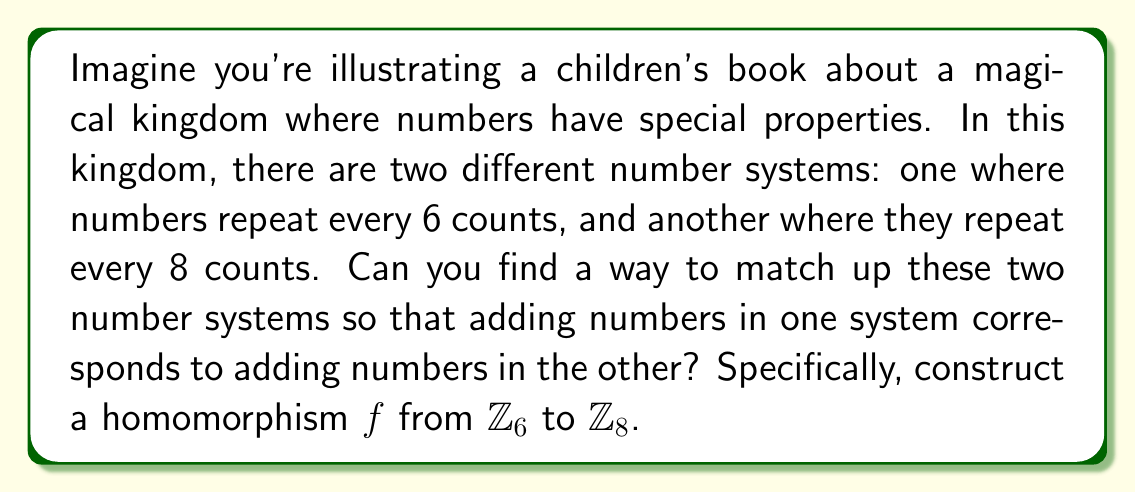Teach me how to tackle this problem. To construct a homomorphism $f: \mathbb{Z}_6 \to \mathbb{Z}_8$, we need to find a function that preserves the addition operation. In other words, for any $a, b \in \mathbb{Z}_6$, we need $f(a + b) = f(a) + f(b)$ (where the addition on the left side is in $\mathbb{Z}_6$ and on the right side is in $\mathbb{Z}_8$).

Let's approach this step-by-step:

1) First, we need to define $f(1)$ in $\mathbb{Z}_8$. Let's say $f(1) = k$ for some $k \in \mathbb{Z}_8$.

2) Once we define $f(1)$, the rest of the function is determined because:
   $f(2) = f(1+1) = f(1) + f(1) = k + k = 2k$
   $f(3) = f(2+1) = f(2) + f(1) = 2k + k = 3k$
   And so on...

3) In general, $f(n) = nk \pmod{8}$ for $n \in \mathbb{Z}_6$

4) Now, we need to ensure that $f(6) = f(0)$ (because 6 ≡ 0 mod 6). This means:
   $6k \equiv 0 \pmod{8}$

5) The smallest positive $k$ that satisfies this is $k = 4$, because $6 \cdot 4 = 24 \equiv 0 \pmod{8}$

6) Therefore, our homomorphism is defined by $f(n) = 4n \pmod{8}$ for $n \in \mathbb{Z}_6$

We can verify this is indeed a homomorphism:
For any $a, b \in \mathbb{Z}_6$:
$f(a+b) = 4(a+b) \pmod{8} = (4a + 4b) \pmod{8} = f(a) + f(b)$

Thus, we have constructed a valid homomorphism from $\mathbb{Z}_6$ to $\mathbb{Z}_8$.
Answer: The homomorphism $f: \mathbb{Z}_6 \to \mathbb{Z}_8$ is given by $f(n) = 4n \pmod{8}$ for $n \in \mathbb{Z}_6$. 